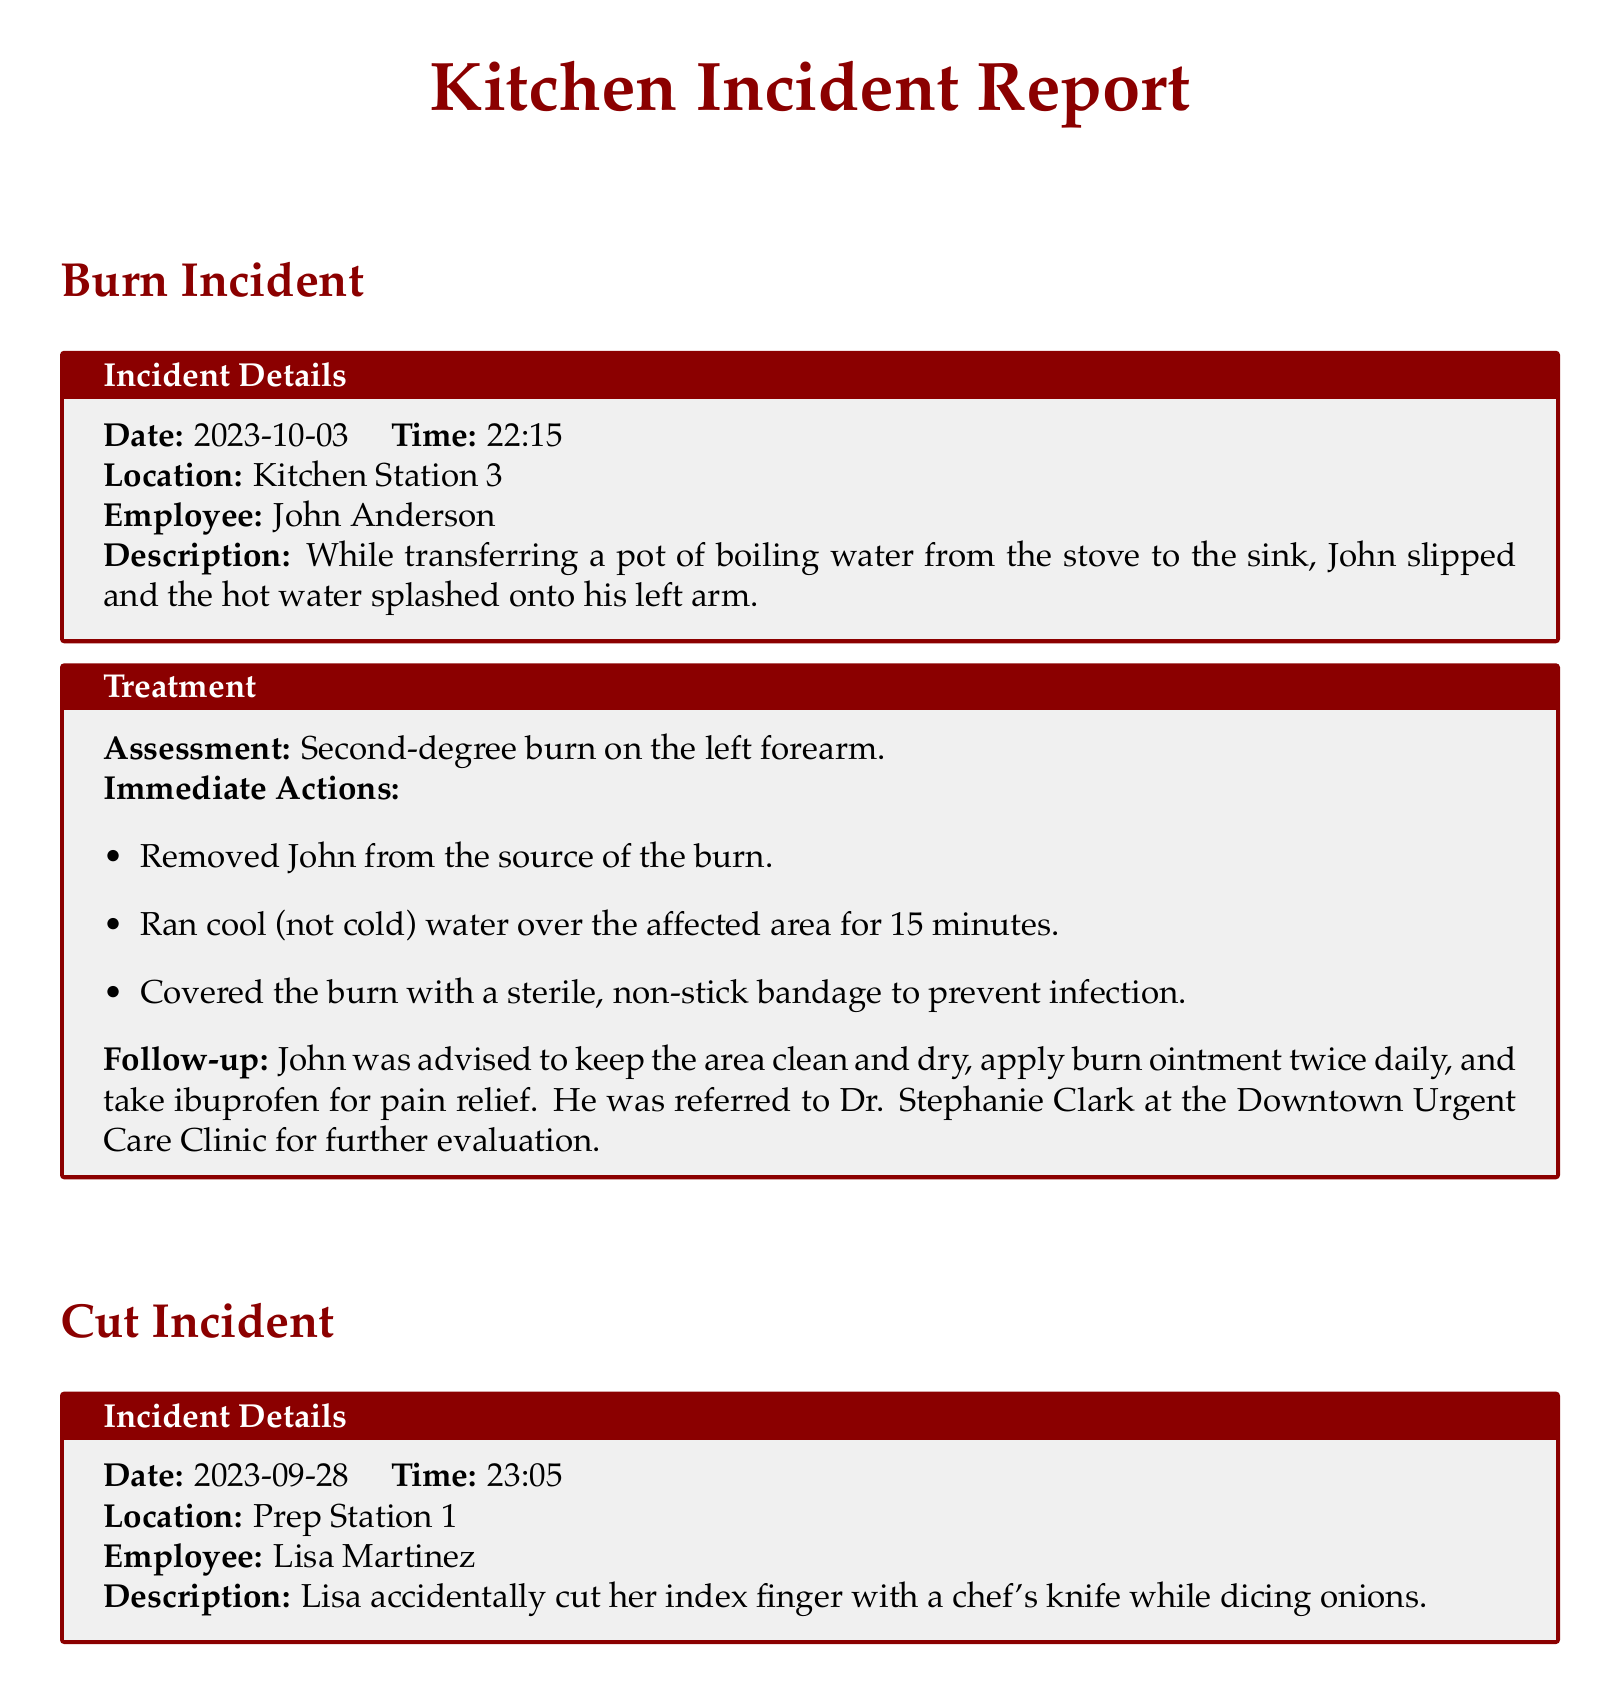What is the date of the burn incident? The date of the burn incident is mentioned directly in the document under the Burn Incident section.
Answer: 2023-10-03 Who was involved in the cut incident? The name of the employee involved in the cut incident is provided in the Cut Incident section.
Answer: Lisa Martinez What type of burn did John Anderson sustain? The treatment section for the burn incident specifies the type of burn sustained by John Anderson.
Answer: Second-degree burn What was the time of the strain incident? The time of the strain incident is listed in the Strain Incident section.
Answer: 21:45 How long was Lisa's cut? The length of Lisa's cut is described in the Treatment section of the Cut Incident.
Answer: Approximately 1.5 cm Which clinic was Richard referred to? The follow-up section of the strain incident indicates the clinic Richard was referred to for further evaluation.
Answer: Mid-City Physical Therapy Clinic What immediate action was taken for the burn incident? The immediate actions taken for the burn incident are listed in the treatment section.
Answer: Ran cool water over the affected area for 15 minutes What was used to treat Richard's lower back? The treatment section of the strain incident states what was applied to Richard's lower back area.
Answer: Ice pack What does Lisa need to monitor for in her wound? The follow-up advice for Lisa includes monitoring for a specific condition regarding her wound.
Answer: Signs of infection 